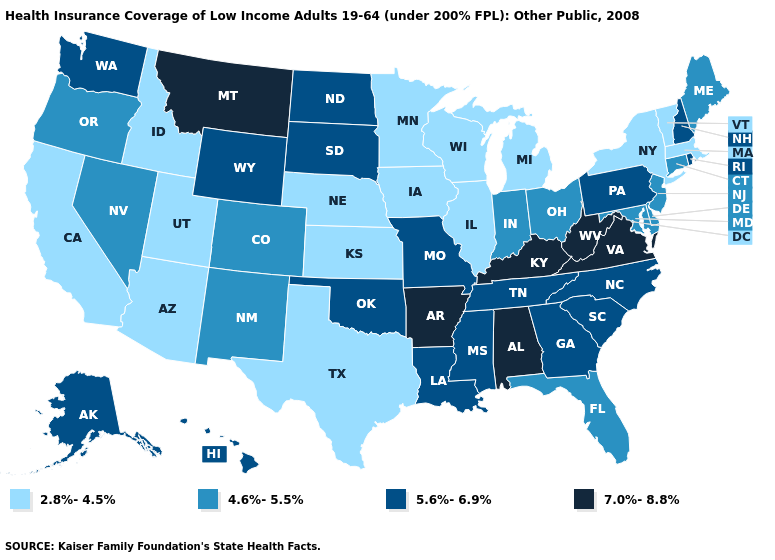Does the map have missing data?
Keep it brief. No. Does Kentucky have the highest value in the South?
Give a very brief answer. Yes. Among the states that border Montana , does Idaho have the highest value?
Quick response, please. No. Which states hav the highest value in the West?
Answer briefly. Montana. How many symbols are there in the legend?
Concise answer only. 4. What is the highest value in states that border West Virginia?
Give a very brief answer. 7.0%-8.8%. What is the lowest value in the USA?
Concise answer only. 2.8%-4.5%. What is the highest value in the West ?
Write a very short answer. 7.0%-8.8%. What is the lowest value in the MidWest?
Keep it brief. 2.8%-4.5%. What is the value of Oklahoma?
Write a very short answer. 5.6%-6.9%. What is the value of Montana?
Short answer required. 7.0%-8.8%. Does New Jersey have the same value as Florida?
Write a very short answer. Yes. Does Nebraska have the same value as Indiana?
Concise answer only. No. What is the value of New Hampshire?
Be succinct. 5.6%-6.9%. 